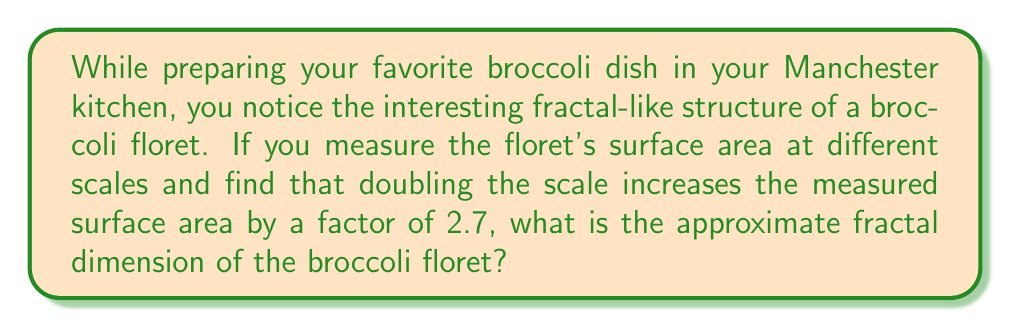Provide a solution to this math problem. To calculate the fractal dimension of the broccoli floret, we'll use the box-counting method and the relationship between scale and measured size.

Step 1: Recall the power law relationship for fractals:
$$ N(r) = cr^{-D} $$
Where $N(r)$ is the number of boxes of size $r$ needed to cover the object, $c$ is a constant, and $D$ is the fractal dimension.

Step 2: In our case, we're dealing with surface area rather than box count. The relationship is similar:
$$ A(s) = cs^{D} $$
Where $A(s)$ is the measured surface area at scale $s$, and $D$ is the fractal dimension we want to find.

Step 3: We're told that doubling the scale increases the measured surface area by a factor of 2.7. Let's express this mathematically:
$$ \frac{A(2s)}{A(s)} = 2.7 $$

Step 4: Substitute the power law relationship:
$$ \frac{c(2s)^D}{cs^D} = 2.7 $$

Step 5: The constant $c$ cancels out:
$$ \frac{2^D s^D}{s^D} = 2.7 $$

Step 6: Simplify:
$$ 2^D = 2.7 $$

Step 7: Take the logarithm of both sides:
$$ D \log 2 = \log 2.7 $$

Step 8: Solve for $D$:
$$ D = \frac{\log 2.7}{\log 2} \approx 1.43 $$

Therefore, the fractal dimension of the broccoli floret is approximately 1.43.
Answer: $1.43$ 